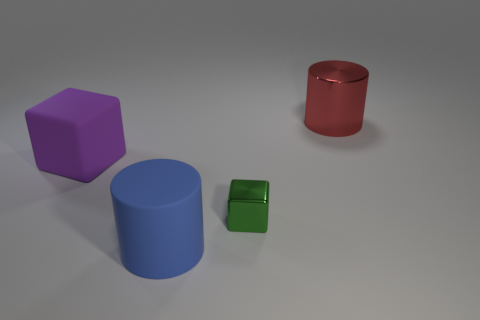Is there anything else of the same color as the large shiny object?
Offer a very short reply. No. Are there fewer large cubes that are on the right side of the tiny metallic thing than large blue cylinders?
Your answer should be very brief. Yes. How many big rubber cubes are there?
Provide a short and direct response. 1. Is the shape of the big purple object the same as the shiny thing that is to the left of the big red object?
Give a very brief answer. Yes. Is the number of big blue cylinders that are right of the large blue cylinder less than the number of purple rubber things that are to the right of the small metallic cube?
Provide a short and direct response. No. Are there any other things that are the same shape as the large blue thing?
Make the answer very short. Yes. Is the shape of the purple matte thing the same as the tiny metal thing?
Offer a very short reply. Yes. Are there any other things that are the same material as the big purple thing?
Your response must be concise. Yes. The blue cylinder is what size?
Ensure brevity in your answer.  Large. The big object that is behind the large blue cylinder and on the right side of the purple matte thing is what color?
Ensure brevity in your answer.  Red. 